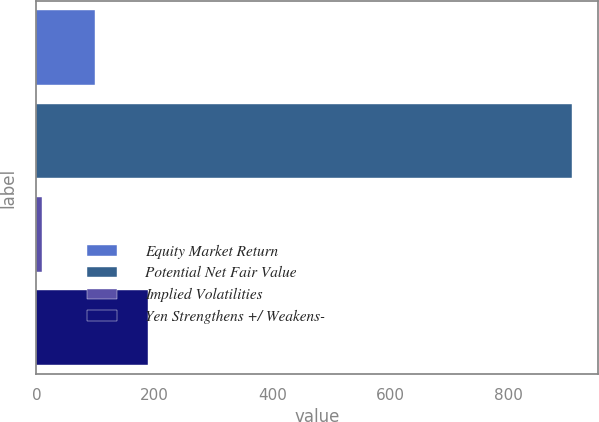Convert chart. <chart><loc_0><loc_0><loc_500><loc_500><bar_chart><fcel>Equity Market Return<fcel>Potential Net Fair Value<fcel>Implied Volatilities<fcel>Yen Strengthens +/ Weakens-<nl><fcel>99.8<fcel>908<fcel>10<fcel>189.6<nl></chart> 